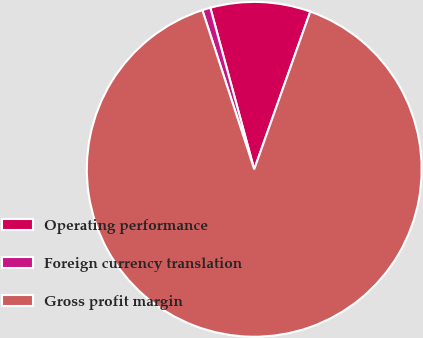Convert chart to OTSL. <chart><loc_0><loc_0><loc_500><loc_500><pie_chart><fcel>Operating performance<fcel>Foreign currency translation<fcel>Gross profit margin<nl><fcel>9.66%<fcel>0.79%<fcel>89.55%<nl></chart> 